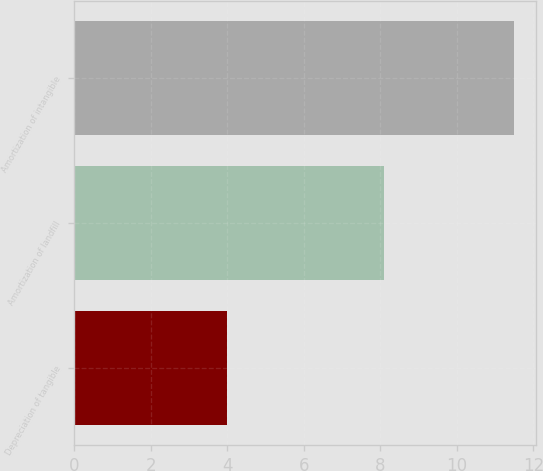<chart> <loc_0><loc_0><loc_500><loc_500><bar_chart><fcel>Depreciation of tangible<fcel>Amortization of landfill<fcel>Amortization of intangible<nl><fcel>4<fcel>8.1<fcel>11.5<nl></chart> 